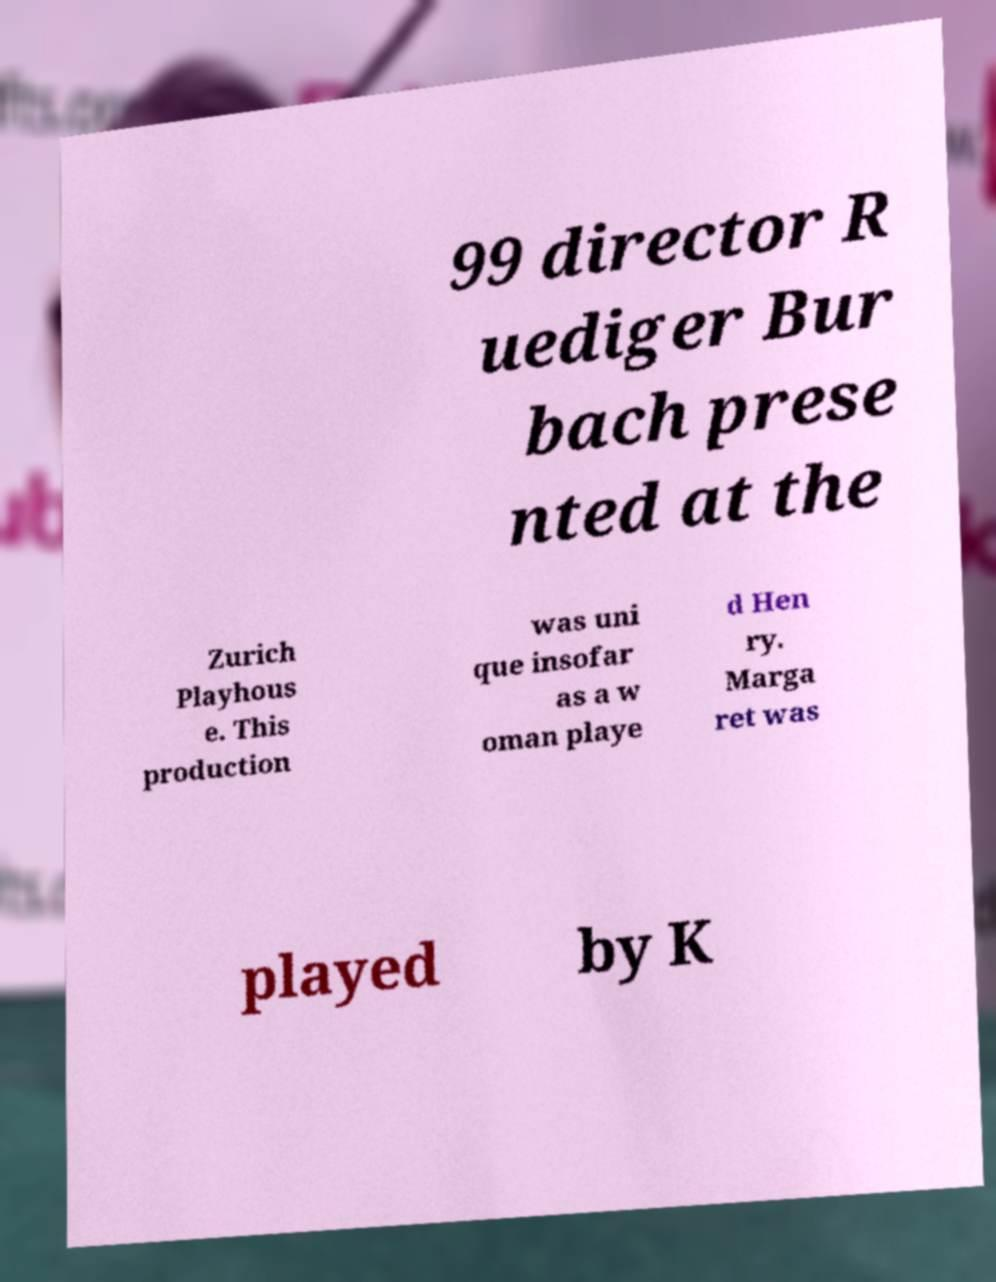Please read and relay the text visible in this image. What does it say? 99 director R uediger Bur bach prese nted at the Zurich Playhous e. This production was uni que insofar as a w oman playe d Hen ry. Marga ret was played by K 